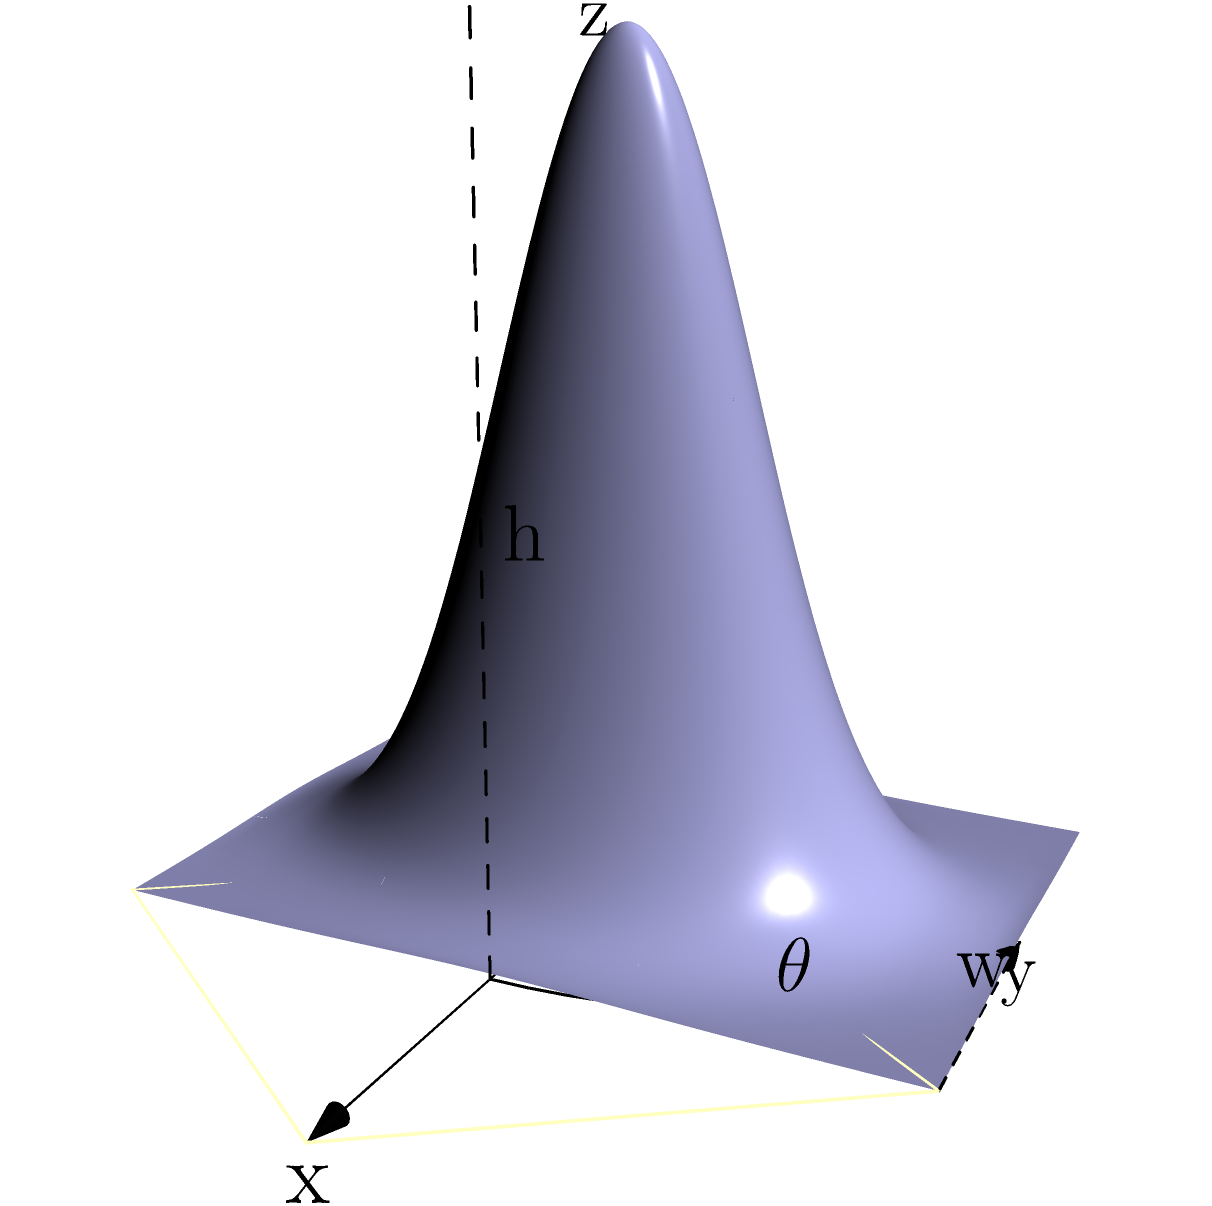A curved railway embankment needs to be constructed with the following specifications:
- The embankment's height (h) follows the function $h(x,y) = 0.5e^{-0.05(x^2+y^2)}$ meters
- The base width (w) is 20 meters
- The embankment extends for a length of 20 meters along a curved track with a central angle ($\theta$) of 30°

Calculate the volume of earthwork required for this embankment using solid geometry principles. Round your answer to the nearest cubic meter. To calculate the volume of the curved embankment, we need to use the method of integration over a curved surface. Here's a step-by-step approach:

1) The volume can be calculated using the triple integral:

   $$V = \int_{0}^{\theta} \int_{0}^{w} \int_{0}^{h(r,\phi)} r \, dz \, dr \, d\phi$$

   where $r$ is the radial distance, $\phi$ is the angle, and $h(r,\phi)$ is the height function.

2) Convert the Cartesian function to polar coordinates:
   $h(x,y) = 0.5e^{-0.05(x^2+y^2)}$ becomes $h(r,\phi) = 0.5e^{-0.05r^2}$

3) Set up the integral:

   $$V = \int_{0}^{\pi/6} \int_{0}^{20} \int_{0}^{0.5e^{-0.05r^2}} r \, dz \, dr \, d\phi$$

4) Solve the innermost integral:

   $$V = \int_{0}^{\pi/6} \int_{0}^{20} 0.5e^{-0.05r^2} \cdot r \, dr \, d\phi$$

5) Solve the middle integral:

   $$V = \int_{0}^{\pi/6} -5(e^{-0.05r^2}-1) \Big|_{0}^{20} \, d\phi$$
   $$= \int_{0}^{\pi/6} -5(e^{-20}-1) \, d\phi$$
   $$= -5(e^{-20}-1) \cdot \phi \Big|_{0}^{\pi/6}$$

6) Solve the outermost integral:

   $$V = -5(e^{-20}-1) \cdot \frac{\pi}{6}$$

7) Calculate the final result:

   $$V \approx 13.0900 \text{ m}^3$$

8) Rounding to the nearest cubic meter:

   $$V \approx 13 \text{ m}^3$$
Answer: 13 m³ 